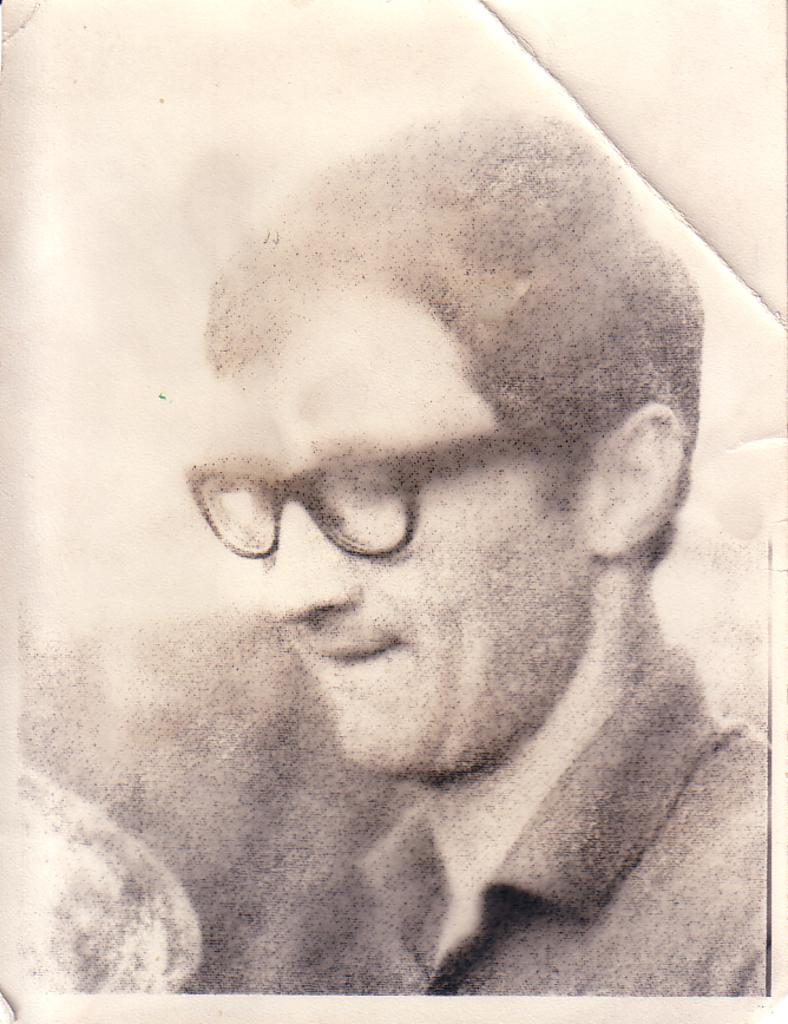What type of photograph is shown in the image? The image is a passport size photograph. Who is in the photograph? There is a man in the image. What is the man wearing in the image? The man is wearing a shirt and spectacles. What type of sweater is the actor wearing in the image? There is no sweater or actor present in the image; it features a man wearing a shirt and spectacles. How does the man's behavior change throughout the image? The image is a still photograph, so there is no indication of the man's behavior changing. 